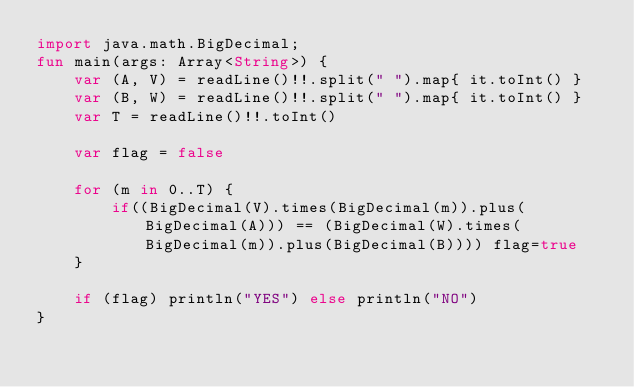Convert code to text. <code><loc_0><loc_0><loc_500><loc_500><_Kotlin_>import java.math.BigDecimal;
fun main(args: Array<String>) {
    var (A, V) = readLine()!!.split(" ").map{ it.toInt() }
    var (B, W) = readLine()!!.split(" ").map{ it.toInt() }
    var T = readLine()!!.toInt()
    
    var flag = false
  
    for (m in 0..T) {
        if((BigDecimal(V).times(BigDecimal(m)).plus(BigDecimal(A))) == (BigDecimal(W).times(BigDecimal(m)).plus(BigDecimal(B)))) flag=true
    }
    
    if (flag) println("YES") else println("NO")
}

</code> 